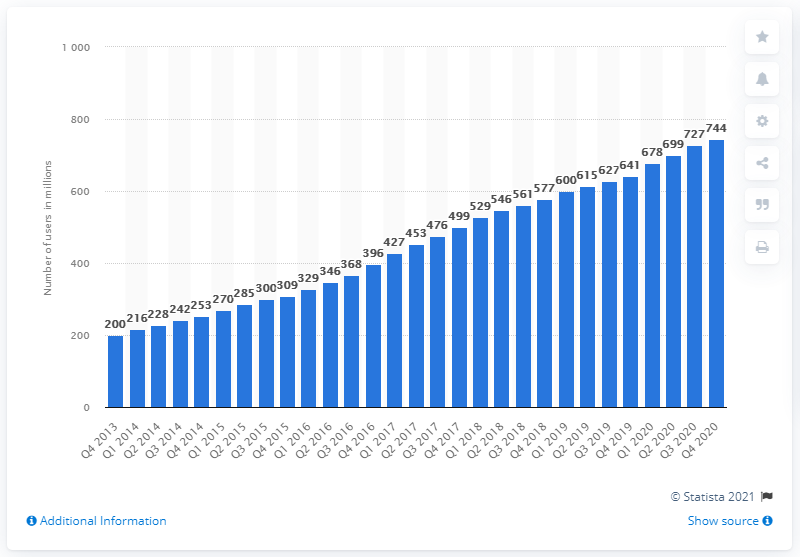Give some essential details in this illustration. In 2013, Facebook had approximately 200 daily active users in the Asia Pacific region. In the fourth quarter of 2020, Facebook had 744 daily active users in the Asia Pacific region. 